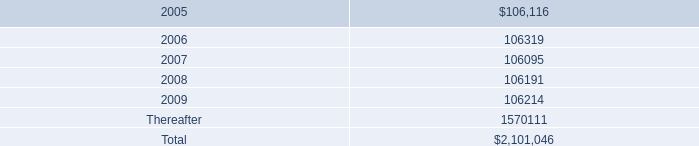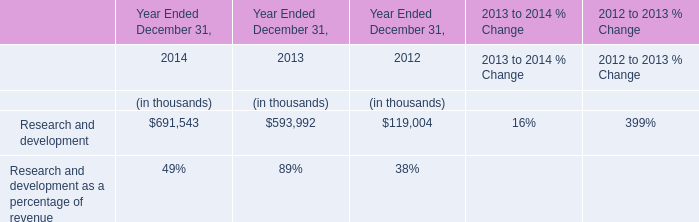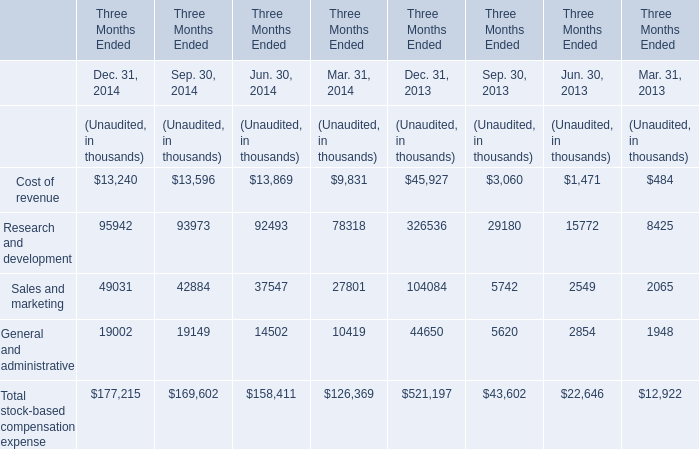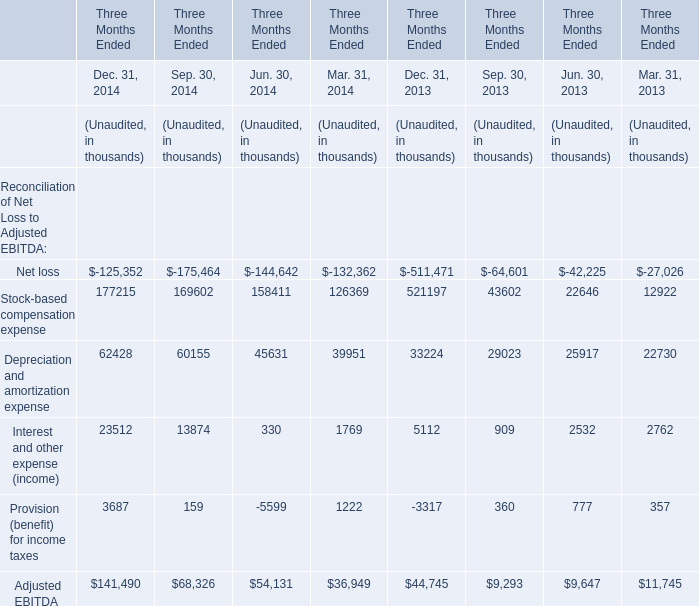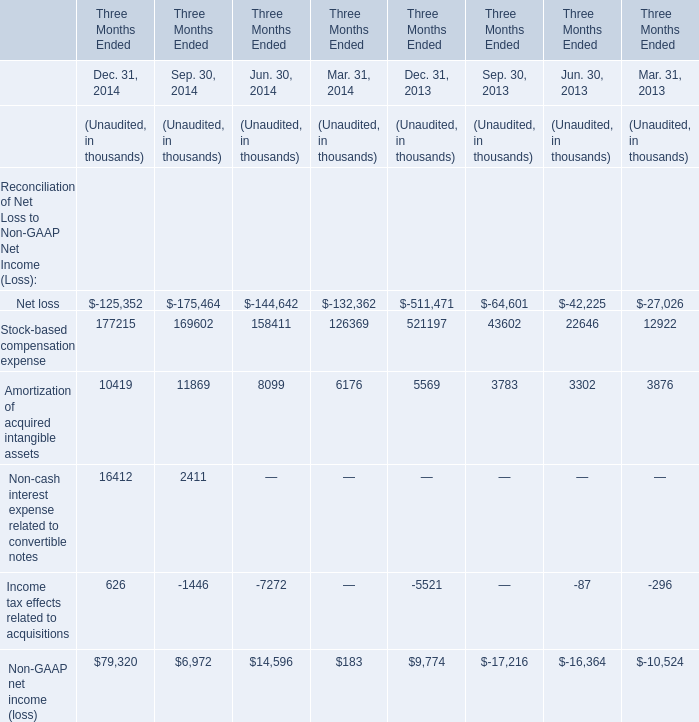what is the percentage change in aggregate rent expense from 2002 to 2003? 
Computations: ((113956000 - 109644000) / 109644000)
Answer: 0.03933. 